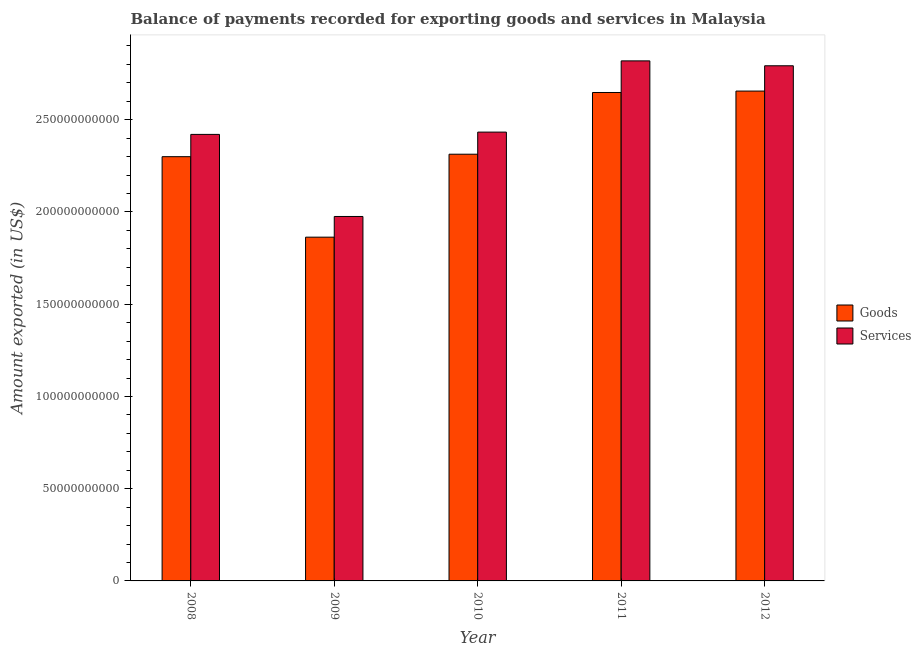How many groups of bars are there?
Your response must be concise. 5. Are the number of bars per tick equal to the number of legend labels?
Your answer should be very brief. Yes. How many bars are there on the 2nd tick from the left?
Your answer should be very brief. 2. In how many cases, is the number of bars for a given year not equal to the number of legend labels?
Offer a terse response. 0. What is the amount of services exported in 2012?
Your answer should be very brief. 2.79e+11. Across all years, what is the maximum amount of goods exported?
Keep it short and to the point. 2.66e+11. Across all years, what is the minimum amount of goods exported?
Provide a short and direct response. 1.86e+11. In which year was the amount of goods exported maximum?
Provide a short and direct response. 2012. What is the total amount of services exported in the graph?
Ensure brevity in your answer.  1.24e+12. What is the difference between the amount of goods exported in 2008 and that in 2010?
Ensure brevity in your answer.  -1.34e+09. What is the difference between the amount of goods exported in 2012 and the amount of services exported in 2009?
Keep it short and to the point. 7.92e+1. What is the average amount of goods exported per year?
Provide a short and direct response. 2.36e+11. In how many years, is the amount of goods exported greater than 170000000000 US$?
Offer a terse response. 5. What is the ratio of the amount of goods exported in 2009 to that in 2011?
Keep it short and to the point. 0.7. What is the difference between the highest and the second highest amount of goods exported?
Your answer should be compact. 7.70e+08. What is the difference between the highest and the lowest amount of goods exported?
Provide a short and direct response. 7.92e+1. What does the 1st bar from the left in 2008 represents?
Keep it short and to the point. Goods. What does the 1st bar from the right in 2010 represents?
Your answer should be very brief. Services. How many bars are there?
Your answer should be compact. 10. How many years are there in the graph?
Give a very brief answer. 5. What is the difference between two consecutive major ticks on the Y-axis?
Offer a terse response. 5.00e+1. Are the values on the major ticks of Y-axis written in scientific E-notation?
Provide a short and direct response. No. Does the graph contain any zero values?
Ensure brevity in your answer.  No. Does the graph contain grids?
Your answer should be very brief. No. Where does the legend appear in the graph?
Give a very brief answer. Center right. How are the legend labels stacked?
Provide a short and direct response. Vertical. What is the title of the graph?
Provide a succinct answer. Balance of payments recorded for exporting goods and services in Malaysia. Does "Gasoline" appear as one of the legend labels in the graph?
Ensure brevity in your answer.  No. What is the label or title of the X-axis?
Keep it short and to the point. Year. What is the label or title of the Y-axis?
Provide a short and direct response. Amount exported (in US$). What is the Amount exported (in US$) in Goods in 2008?
Your response must be concise. 2.30e+11. What is the Amount exported (in US$) in Services in 2008?
Give a very brief answer. 2.42e+11. What is the Amount exported (in US$) of Goods in 2009?
Your response must be concise. 1.86e+11. What is the Amount exported (in US$) in Services in 2009?
Offer a very short reply. 1.98e+11. What is the Amount exported (in US$) in Goods in 2010?
Ensure brevity in your answer.  2.31e+11. What is the Amount exported (in US$) of Services in 2010?
Make the answer very short. 2.43e+11. What is the Amount exported (in US$) of Goods in 2011?
Offer a terse response. 2.65e+11. What is the Amount exported (in US$) of Services in 2011?
Give a very brief answer. 2.82e+11. What is the Amount exported (in US$) in Goods in 2012?
Give a very brief answer. 2.66e+11. What is the Amount exported (in US$) in Services in 2012?
Offer a terse response. 2.79e+11. Across all years, what is the maximum Amount exported (in US$) in Goods?
Your response must be concise. 2.66e+11. Across all years, what is the maximum Amount exported (in US$) in Services?
Give a very brief answer. 2.82e+11. Across all years, what is the minimum Amount exported (in US$) of Goods?
Your response must be concise. 1.86e+11. Across all years, what is the minimum Amount exported (in US$) of Services?
Your response must be concise. 1.98e+11. What is the total Amount exported (in US$) in Goods in the graph?
Give a very brief answer. 1.18e+12. What is the total Amount exported (in US$) in Services in the graph?
Make the answer very short. 1.24e+12. What is the difference between the Amount exported (in US$) in Goods in 2008 and that in 2009?
Give a very brief answer. 4.36e+1. What is the difference between the Amount exported (in US$) of Services in 2008 and that in 2009?
Give a very brief answer. 4.45e+1. What is the difference between the Amount exported (in US$) in Goods in 2008 and that in 2010?
Your answer should be very brief. -1.34e+09. What is the difference between the Amount exported (in US$) in Services in 2008 and that in 2010?
Provide a short and direct response. -1.25e+09. What is the difference between the Amount exported (in US$) in Goods in 2008 and that in 2011?
Give a very brief answer. -3.48e+1. What is the difference between the Amount exported (in US$) in Services in 2008 and that in 2011?
Make the answer very short. -3.99e+1. What is the difference between the Amount exported (in US$) of Goods in 2008 and that in 2012?
Provide a short and direct response. -3.56e+1. What is the difference between the Amount exported (in US$) of Services in 2008 and that in 2012?
Your answer should be compact. -3.72e+1. What is the difference between the Amount exported (in US$) in Goods in 2009 and that in 2010?
Give a very brief answer. -4.50e+1. What is the difference between the Amount exported (in US$) of Services in 2009 and that in 2010?
Give a very brief answer. -4.57e+1. What is the difference between the Amount exported (in US$) of Goods in 2009 and that in 2011?
Provide a succinct answer. -7.84e+1. What is the difference between the Amount exported (in US$) of Services in 2009 and that in 2011?
Give a very brief answer. -8.43e+1. What is the difference between the Amount exported (in US$) in Goods in 2009 and that in 2012?
Your answer should be very brief. -7.92e+1. What is the difference between the Amount exported (in US$) of Services in 2009 and that in 2012?
Provide a short and direct response. -8.17e+1. What is the difference between the Amount exported (in US$) in Goods in 2010 and that in 2011?
Make the answer very short. -3.35e+1. What is the difference between the Amount exported (in US$) in Services in 2010 and that in 2011?
Your response must be concise. -3.86e+1. What is the difference between the Amount exported (in US$) of Goods in 2010 and that in 2012?
Offer a terse response. -3.42e+1. What is the difference between the Amount exported (in US$) of Services in 2010 and that in 2012?
Provide a succinct answer. -3.60e+1. What is the difference between the Amount exported (in US$) in Goods in 2011 and that in 2012?
Make the answer very short. -7.70e+08. What is the difference between the Amount exported (in US$) of Services in 2011 and that in 2012?
Make the answer very short. 2.66e+09. What is the difference between the Amount exported (in US$) of Goods in 2008 and the Amount exported (in US$) of Services in 2009?
Your response must be concise. 3.24e+1. What is the difference between the Amount exported (in US$) of Goods in 2008 and the Amount exported (in US$) of Services in 2010?
Your response must be concise. -1.33e+1. What is the difference between the Amount exported (in US$) in Goods in 2008 and the Amount exported (in US$) in Services in 2011?
Offer a terse response. -5.19e+1. What is the difference between the Amount exported (in US$) in Goods in 2008 and the Amount exported (in US$) in Services in 2012?
Give a very brief answer. -4.93e+1. What is the difference between the Amount exported (in US$) in Goods in 2009 and the Amount exported (in US$) in Services in 2010?
Your answer should be compact. -5.70e+1. What is the difference between the Amount exported (in US$) of Goods in 2009 and the Amount exported (in US$) of Services in 2011?
Offer a very short reply. -9.56e+1. What is the difference between the Amount exported (in US$) in Goods in 2009 and the Amount exported (in US$) in Services in 2012?
Offer a very short reply. -9.29e+1. What is the difference between the Amount exported (in US$) in Goods in 2010 and the Amount exported (in US$) in Services in 2011?
Ensure brevity in your answer.  -5.06e+1. What is the difference between the Amount exported (in US$) in Goods in 2010 and the Amount exported (in US$) in Services in 2012?
Provide a succinct answer. -4.79e+1. What is the difference between the Amount exported (in US$) of Goods in 2011 and the Amount exported (in US$) of Services in 2012?
Make the answer very short. -1.45e+1. What is the average Amount exported (in US$) in Goods per year?
Provide a short and direct response. 2.36e+11. What is the average Amount exported (in US$) in Services per year?
Your answer should be very brief. 2.49e+11. In the year 2008, what is the difference between the Amount exported (in US$) of Goods and Amount exported (in US$) of Services?
Give a very brief answer. -1.21e+1. In the year 2009, what is the difference between the Amount exported (in US$) of Goods and Amount exported (in US$) of Services?
Offer a very short reply. -1.12e+1. In the year 2010, what is the difference between the Amount exported (in US$) of Goods and Amount exported (in US$) of Services?
Make the answer very short. -1.20e+1. In the year 2011, what is the difference between the Amount exported (in US$) in Goods and Amount exported (in US$) in Services?
Offer a terse response. -1.71e+1. In the year 2012, what is the difference between the Amount exported (in US$) of Goods and Amount exported (in US$) of Services?
Your answer should be very brief. -1.37e+1. What is the ratio of the Amount exported (in US$) in Goods in 2008 to that in 2009?
Provide a succinct answer. 1.23. What is the ratio of the Amount exported (in US$) in Services in 2008 to that in 2009?
Offer a terse response. 1.23. What is the ratio of the Amount exported (in US$) in Goods in 2008 to that in 2011?
Offer a very short reply. 0.87. What is the ratio of the Amount exported (in US$) of Services in 2008 to that in 2011?
Make the answer very short. 0.86. What is the ratio of the Amount exported (in US$) in Goods in 2008 to that in 2012?
Provide a short and direct response. 0.87. What is the ratio of the Amount exported (in US$) of Services in 2008 to that in 2012?
Make the answer very short. 0.87. What is the ratio of the Amount exported (in US$) of Goods in 2009 to that in 2010?
Your answer should be very brief. 0.81. What is the ratio of the Amount exported (in US$) in Services in 2009 to that in 2010?
Ensure brevity in your answer.  0.81. What is the ratio of the Amount exported (in US$) of Goods in 2009 to that in 2011?
Make the answer very short. 0.7. What is the ratio of the Amount exported (in US$) of Services in 2009 to that in 2011?
Ensure brevity in your answer.  0.7. What is the ratio of the Amount exported (in US$) of Goods in 2009 to that in 2012?
Your answer should be very brief. 0.7. What is the ratio of the Amount exported (in US$) in Services in 2009 to that in 2012?
Ensure brevity in your answer.  0.71. What is the ratio of the Amount exported (in US$) of Goods in 2010 to that in 2011?
Provide a short and direct response. 0.87. What is the ratio of the Amount exported (in US$) of Services in 2010 to that in 2011?
Offer a very short reply. 0.86. What is the ratio of the Amount exported (in US$) of Goods in 2010 to that in 2012?
Keep it short and to the point. 0.87. What is the ratio of the Amount exported (in US$) in Services in 2010 to that in 2012?
Make the answer very short. 0.87. What is the ratio of the Amount exported (in US$) in Goods in 2011 to that in 2012?
Your answer should be compact. 1. What is the ratio of the Amount exported (in US$) in Services in 2011 to that in 2012?
Give a very brief answer. 1.01. What is the difference between the highest and the second highest Amount exported (in US$) of Goods?
Keep it short and to the point. 7.70e+08. What is the difference between the highest and the second highest Amount exported (in US$) of Services?
Keep it short and to the point. 2.66e+09. What is the difference between the highest and the lowest Amount exported (in US$) of Goods?
Your answer should be very brief. 7.92e+1. What is the difference between the highest and the lowest Amount exported (in US$) of Services?
Your answer should be compact. 8.43e+1. 